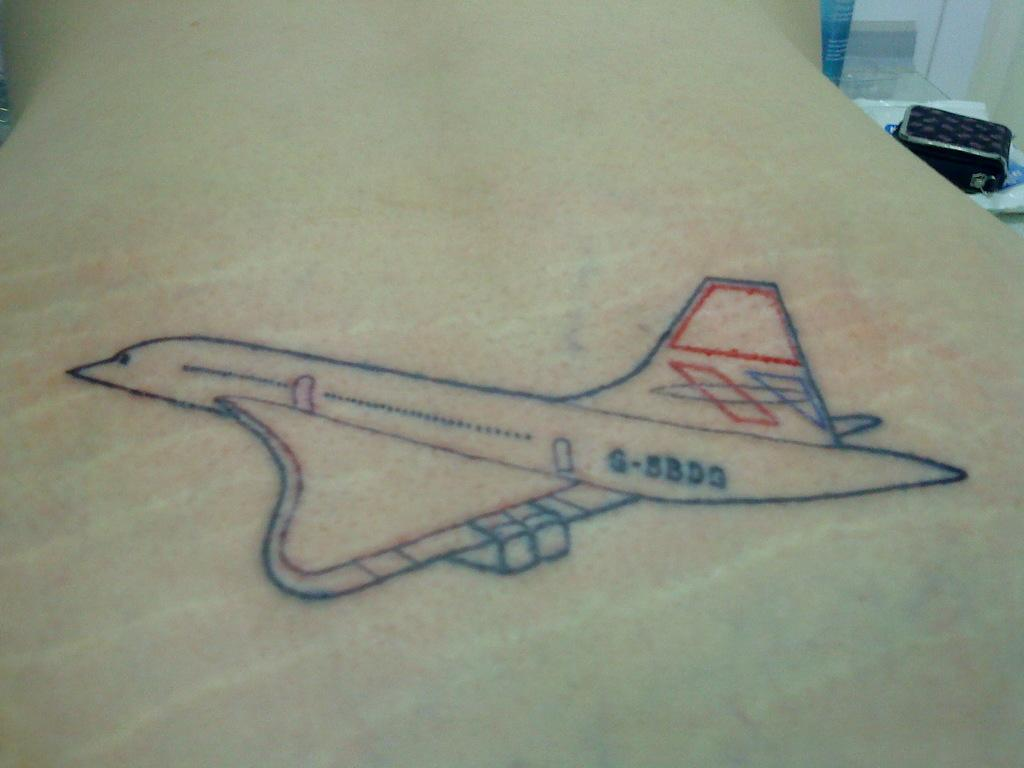<image>
Create a compact narrative representing the image presented. a drawing of an airplane with serial number G-5BDG on a table 